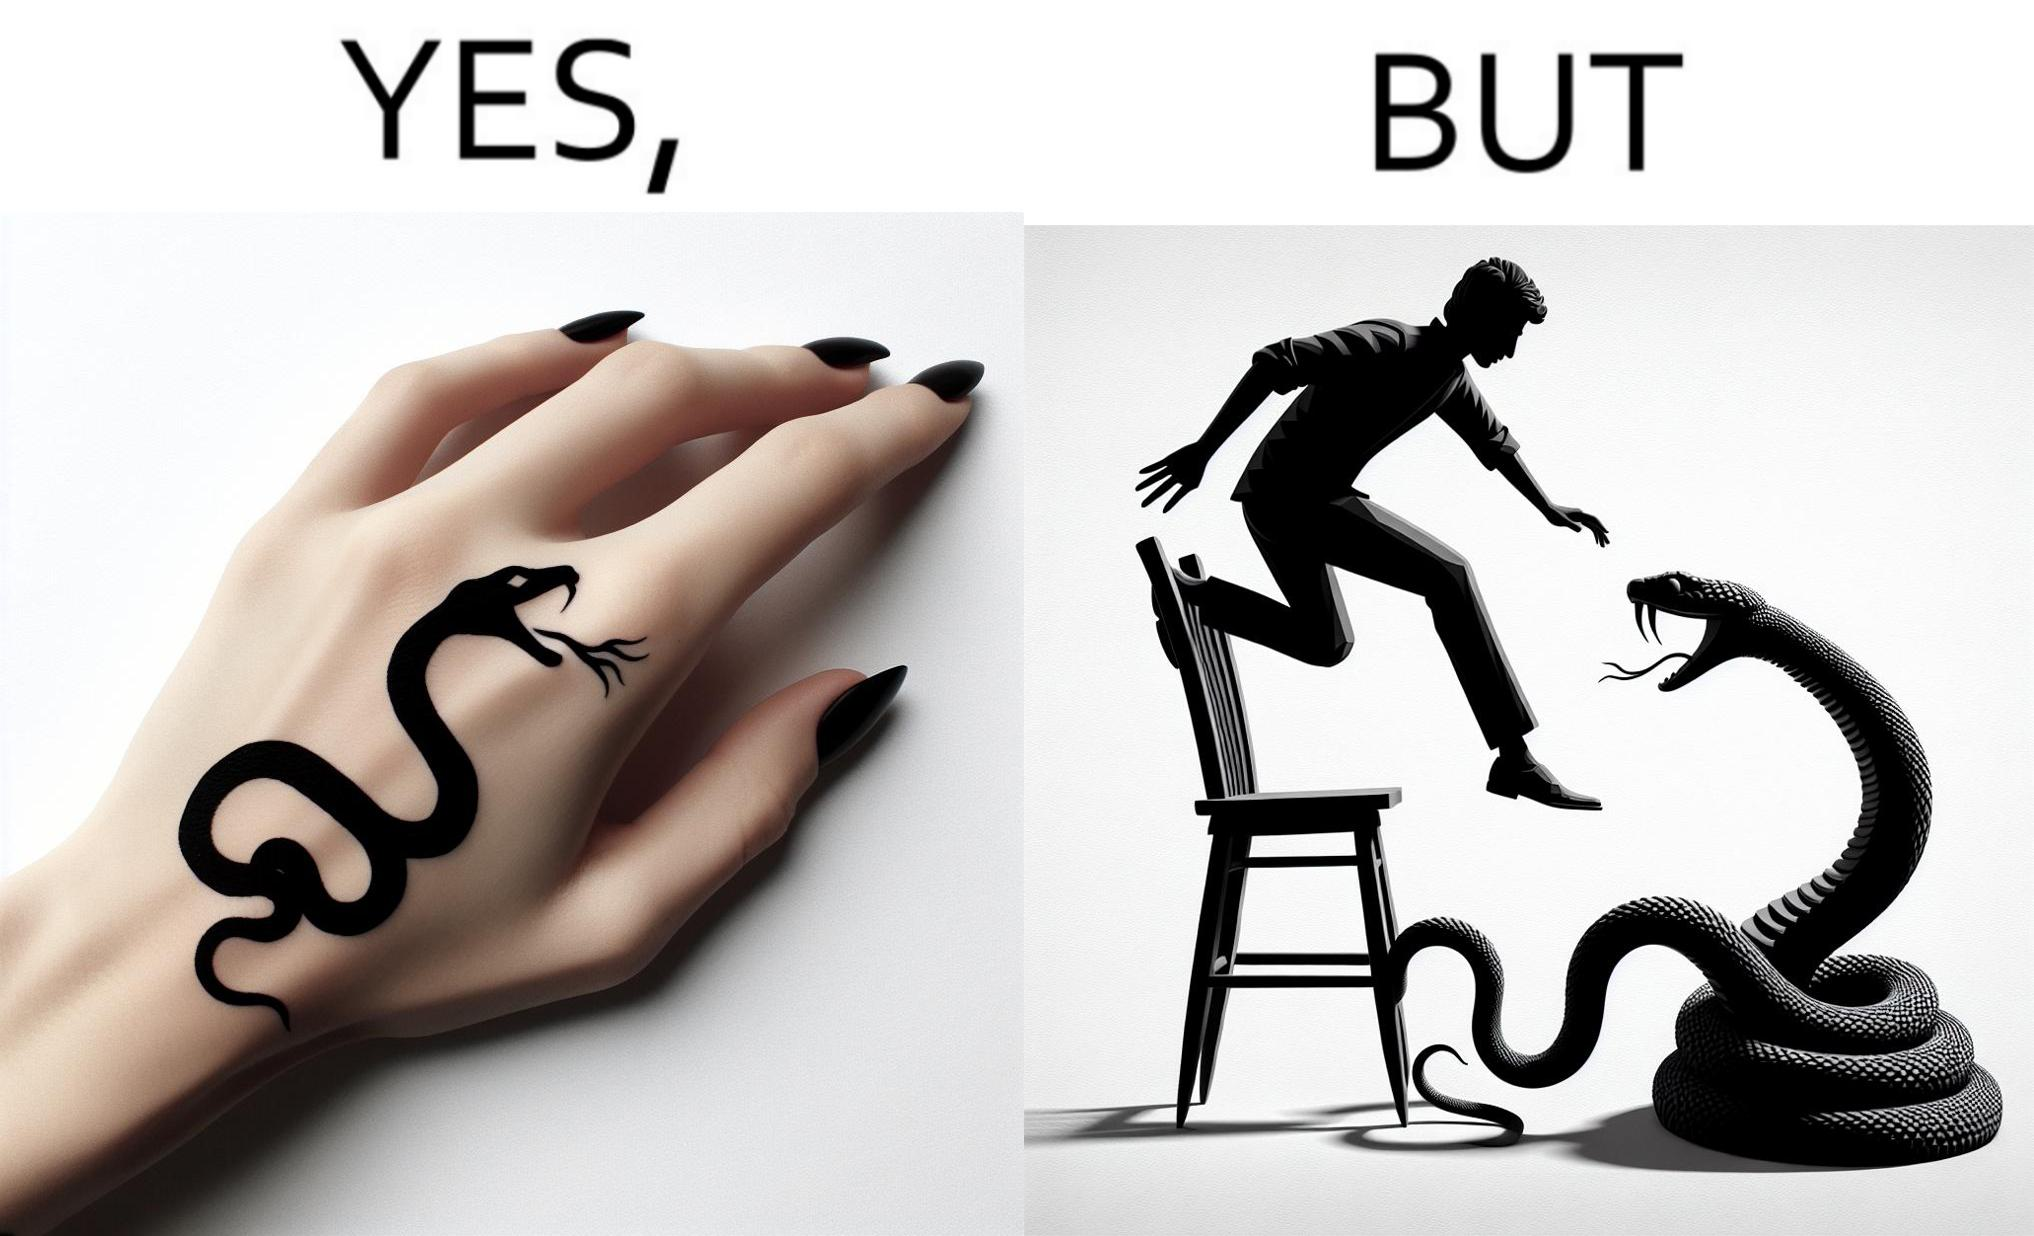Describe the content of this image. The image is ironic, because in the first image the tattoo of a snake on someone's hand may give us a hint about how powerful or brave the person can be who is having this tattoo but in the second image the person with same tattoo is seen frightened due to a snake in his house 